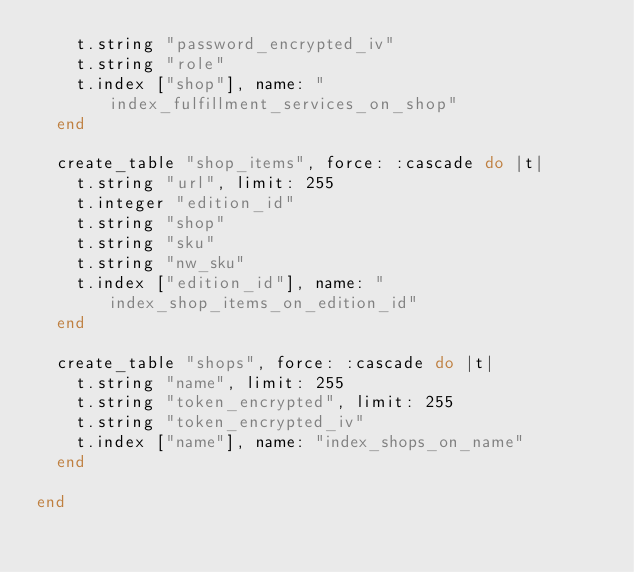<code> <loc_0><loc_0><loc_500><loc_500><_Ruby_>    t.string "password_encrypted_iv"
    t.string "role"
    t.index ["shop"], name: "index_fulfillment_services_on_shop"
  end

  create_table "shop_items", force: :cascade do |t|
    t.string "url", limit: 255
    t.integer "edition_id"
    t.string "shop"
    t.string "sku"
    t.string "nw_sku"
    t.index ["edition_id"], name: "index_shop_items_on_edition_id"
  end

  create_table "shops", force: :cascade do |t|
    t.string "name", limit: 255
    t.string "token_encrypted", limit: 255
    t.string "token_encrypted_iv"
    t.index ["name"], name: "index_shops_on_name"
  end

end
</code> 